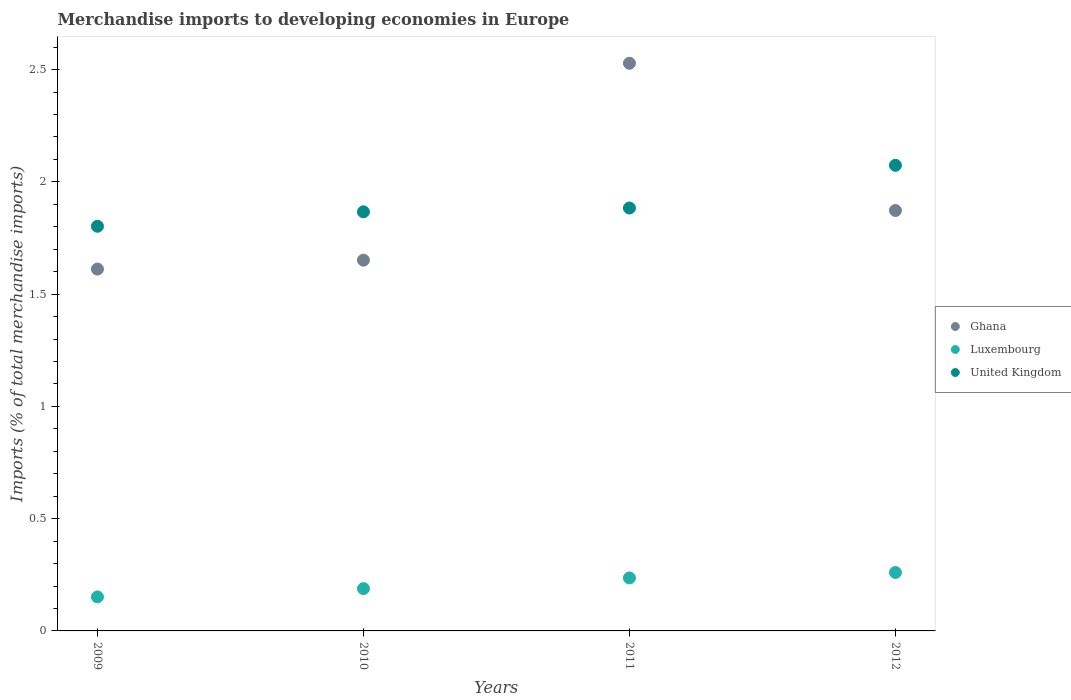How many different coloured dotlines are there?
Your answer should be compact. 3. Is the number of dotlines equal to the number of legend labels?
Your answer should be very brief. Yes. What is the percentage total merchandise imports in Ghana in 2009?
Offer a very short reply. 1.61. Across all years, what is the maximum percentage total merchandise imports in Ghana?
Your response must be concise. 2.53. Across all years, what is the minimum percentage total merchandise imports in Ghana?
Give a very brief answer. 1.61. In which year was the percentage total merchandise imports in Ghana minimum?
Your response must be concise. 2009. What is the total percentage total merchandise imports in Ghana in the graph?
Provide a succinct answer. 7.66. What is the difference between the percentage total merchandise imports in United Kingdom in 2011 and that in 2012?
Your answer should be very brief. -0.19. What is the difference between the percentage total merchandise imports in United Kingdom in 2012 and the percentage total merchandise imports in Luxembourg in 2010?
Make the answer very short. 1.89. What is the average percentage total merchandise imports in Ghana per year?
Give a very brief answer. 1.92. In the year 2010, what is the difference between the percentage total merchandise imports in Luxembourg and percentage total merchandise imports in United Kingdom?
Offer a very short reply. -1.68. In how many years, is the percentage total merchandise imports in Ghana greater than 1 %?
Your answer should be compact. 4. What is the ratio of the percentage total merchandise imports in Luxembourg in 2010 to that in 2011?
Provide a succinct answer. 0.8. Is the percentage total merchandise imports in Ghana in 2011 less than that in 2012?
Your answer should be compact. No. Is the difference between the percentage total merchandise imports in Luxembourg in 2010 and 2012 greater than the difference between the percentage total merchandise imports in United Kingdom in 2010 and 2012?
Ensure brevity in your answer.  Yes. What is the difference between the highest and the second highest percentage total merchandise imports in Ghana?
Give a very brief answer. 0.66. What is the difference between the highest and the lowest percentage total merchandise imports in Ghana?
Your response must be concise. 0.92. Is the sum of the percentage total merchandise imports in Ghana in 2009 and 2010 greater than the maximum percentage total merchandise imports in Luxembourg across all years?
Keep it short and to the point. Yes. Does the percentage total merchandise imports in Luxembourg monotonically increase over the years?
Make the answer very short. Yes. Is the percentage total merchandise imports in Ghana strictly greater than the percentage total merchandise imports in Luxembourg over the years?
Give a very brief answer. Yes. Does the graph contain grids?
Offer a very short reply. No. How many legend labels are there?
Keep it short and to the point. 3. How are the legend labels stacked?
Provide a short and direct response. Vertical. What is the title of the graph?
Provide a short and direct response. Merchandise imports to developing economies in Europe. Does "New Zealand" appear as one of the legend labels in the graph?
Your answer should be very brief. No. What is the label or title of the X-axis?
Your response must be concise. Years. What is the label or title of the Y-axis?
Your answer should be compact. Imports (% of total merchandise imports). What is the Imports (% of total merchandise imports) in Ghana in 2009?
Give a very brief answer. 1.61. What is the Imports (% of total merchandise imports) of Luxembourg in 2009?
Provide a short and direct response. 0.15. What is the Imports (% of total merchandise imports) of United Kingdom in 2009?
Provide a short and direct response. 1.8. What is the Imports (% of total merchandise imports) of Ghana in 2010?
Your answer should be compact. 1.65. What is the Imports (% of total merchandise imports) in Luxembourg in 2010?
Make the answer very short. 0.19. What is the Imports (% of total merchandise imports) of United Kingdom in 2010?
Your answer should be compact. 1.87. What is the Imports (% of total merchandise imports) of Ghana in 2011?
Provide a short and direct response. 2.53. What is the Imports (% of total merchandise imports) of Luxembourg in 2011?
Offer a terse response. 0.24. What is the Imports (% of total merchandise imports) of United Kingdom in 2011?
Your response must be concise. 1.88. What is the Imports (% of total merchandise imports) of Ghana in 2012?
Ensure brevity in your answer.  1.87. What is the Imports (% of total merchandise imports) of Luxembourg in 2012?
Give a very brief answer. 0.26. What is the Imports (% of total merchandise imports) in United Kingdom in 2012?
Provide a succinct answer. 2.07. Across all years, what is the maximum Imports (% of total merchandise imports) in Ghana?
Provide a short and direct response. 2.53. Across all years, what is the maximum Imports (% of total merchandise imports) in Luxembourg?
Provide a short and direct response. 0.26. Across all years, what is the maximum Imports (% of total merchandise imports) of United Kingdom?
Your answer should be compact. 2.07. Across all years, what is the minimum Imports (% of total merchandise imports) in Ghana?
Give a very brief answer. 1.61. Across all years, what is the minimum Imports (% of total merchandise imports) of Luxembourg?
Provide a succinct answer. 0.15. Across all years, what is the minimum Imports (% of total merchandise imports) in United Kingdom?
Your answer should be compact. 1.8. What is the total Imports (% of total merchandise imports) in Ghana in the graph?
Your response must be concise. 7.66. What is the total Imports (% of total merchandise imports) in Luxembourg in the graph?
Give a very brief answer. 0.84. What is the total Imports (% of total merchandise imports) in United Kingdom in the graph?
Your answer should be compact. 7.63. What is the difference between the Imports (% of total merchandise imports) in Ghana in 2009 and that in 2010?
Give a very brief answer. -0.04. What is the difference between the Imports (% of total merchandise imports) in Luxembourg in 2009 and that in 2010?
Offer a terse response. -0.04. What is the difference between the Imports (% of total merchandise imports) in United Kingdom in 2009 and that in 2010?
Offer a terse response. -0.06. What is the difference between the Imports (% of total merchandise imports) of Ghana in 2009 and that in 2011?
Provide a succinct answer. -0.92. What is the difference between the Imports (% of total merchandise imports) of Luxembourg in 2009 and that in 2011?
Make the answer very short. -0.08. What is the difference between the Imports (% of total merchandise imports) in United Kingdom in 2009 and that in 2011?
Give a very brief answer. -0.08. What is the difference between the Imports (% of total merchandise imports) in Ghana in 2009 and that in 2012?
Give a very brief answer. -0.26. What is the difference between the Imports (% of total merchandise imports) in Luxembourg in 2009 and that in 2012?
Keep it short and to the point. -0.11. What is the difference between the Imports (% of total merchandise imports) of United Kingdom in 2009 and that in 2012?
Offer a terse response. -0.27. What is the difference between the Imports (% of total merchandise imports) in Ghana in 2010 and that in 2011?
Provide a short and direct response. -0.88. What is the difference between the Imports (% of total merchandise imports) of Luxembourg in 2010 and that in 2011?
Offer a terse response. -0.05. What is the difference between the Imports (% of total merchandise imports) in United Kingdom in 2010 and that in 2011?
Keep it short and to the point. -0.02. What is the difference between the Imports (% of total merchandise imports) of Ghana in 2010 and that in 2012?
Provide a short and direct response. -0.22. What is the difference between the Imports (% of total merchandise imports) of Luxembourg in 2010 and that in 2012?
Provide a succinct answer. -0.07. What is the difference between the Imports (% of total merchandise imports) in United Kingdom in 2010 and that in 2012?
Your answer should be very brief. -0.21. What is the difference between the Imports (% of total merchandise imports) of Ghana in 2011 and that in 2012?
Provide a short and direct response. 0.66. What is the difference between the Imports (% of total merchandise imports) in Luxembourg in 2011 and that in 2012?
Offer a very short reply. -0.02. What is the difference between the Imports (% of total merchandise imports) in United Kingdom in 2011 and that in 2012?
Ensure brevity in your answer.  -0.19. What is the difference between the Imports (% of total merchandise imports) of Ghana in 2009 and the Imports (% of total merchandise imports) of Luxembourg in 2010?
Your response must be concise. 1.42. What is the difference between the Imports (% of total merchandise imports) in Ghana in 2009 and the Imports (% of total merchandise imports) in United Kingdom in 2010?
Your response must be concise. -0.25. What is the difference between the Imports (% of total merchandise imports) of Luxembourg in 2009 and the Imports (% of total merchandise imports) of United Kingdom in 2010?
Your response must be concise. -1.71. What is the difference between the Imports (% of total merchandise imports) in Ghana in 2009 and the Imports (% of total merchandise imports) in Luxembourg in 2011?
Provide a short and direct response. 1.38. What is the difference between the Imports (% of total merchandise imports) in Ghana in 2009 and the Imports (% of total merchandise imports) in United Kingdom in 2011?
Give a very brief answer. -0.27. What is the difference between the Imports (% of total merchandise imports) in Luxembourg in 2009 and the Imports (% of total merchandise imports) in United Kingdom in 2011?
Offer a terse response. -1.73. What is the difference between the Imports (% of total merchandise imports) of Ghana in 2009 and the Imports (% of total merchandise imports) of Luxembourg in 2012?
Offer a very short reply. 1.35. What is the difference between the Imports (% of total merchandise imports) of Ghana in 2009 and the Imports (% of total merchandise imports) of United Kingdom in 2012?
Your answer should be very brief. -0.46. What is the difference between the Imports (% of total merchandise imports) of Luxembourg in 2009 and the Imports (% of total merchandise imports) of United Kingdom in 2012?
Keep it short and to the point. -1.92. What is the difference between the Imports (% of total merchandise imports) of Ghana in 2010 and the Imports (% of total merchandise imports) of Luxembourg in 2011?
Your answer should be compact. 1.42. What is the difference between the Imports (% of total merchandise imports) in Ghana in 2010 and the Imports (% of total merchandise imports) in United Kingdom in 2011?
Keep it short and to the point. -0.23. What is the difference between the Imports (% of total merchandise imports) of Luxembourg in 2010 and the Imports (% of total merchandise imports) of United Kingdom in 2011?
Your answer should be very brief. -1.7. What is the difference between the Imports (% of total merchandise imports) of Ghana in 2010 and the Imports (% of total merchandise imports) of Luxembourg in 2012?
Make the answer very short. 1.39. What is the difference between the Imports (% of total merchandise imports) of Ghana in 2010 and the Imports (% of total merchandise imports) of United Kingdom in 2012?
Your response must be concise. -0.42. What is the difference between the Imports (% of total merchandise imports) of Luxembourg in 2010 and the Imports (% of total merchandise imports) of United Kingdom in 2012?
Ensure brevity in your answer.  -1.89. What is the difference between the Imports (% of total merchandise imports) of Ghana in 2011 and the Imports (% of total merchandise imports) of Luxembourg in 2012?
Provide a succinct answer. 2.27. What is the difference between the Imports (% of total merchandise imports) in Ghana in 2011 and the Imports (% of total merchandise imports) in United Kingdom in 2012?
Offer a very short reply. 0.45. What is the difference between the Imports (% of total merchandise imports) in Luxembourg in 2011 and the Imports (% of total merchandise imports) in United Kingdom in 2012?
Your answer should be compact. -1.84. What is the average Imports (% of total merchandise imports) of Ghana per year?
Give a very brief answer. 1.92. What is the average Imports (% of total merchandise imports) in Luxembourg per year?
Give a very brief answer. 0.21. What is the average Imports (% of total merchandise imports) in United Kingdom per year?
Give a very brief answer. 1.91. In the year 2009, what is the difference between the Imports (% of total merchandise imports) of Ghana and Imports (% of total merchandise imports) of Luxembourg?
Offer a terse response. 1.46. In the year 2009, what is the difference between the Imports (% of total merchandise imports) in Ghana and Imports (% of total merchandise imports) in United Kingdom?
Ensure brevity in your answer.  -0.19. In the year 2009, what is the difference between the Imports (% of total merchandise imports) of Luxembourg and Imports (% of total merchandise imports) of United Kingdom?
Keep it short and to the point. -1.65. In the year 2010, what is the difference between the Imports (% of total merchandise imports) in Ghana and Imports (% of total merchandise imports) in Luxembourg?
Give a very brief answer. 1.46. In the year 2010, what is the difference between the Imports (% of total merchandise imports) of Ghana and Imports (% of total merchandise imports) of United Kingdom?
Provide a short and direct response. -0.22. In the year 2010, what is the difference between the Imports (% of total merchandise imports) in Luxembourg and Imports (% of total merchandise imports) in United Kingdom?
Provide a succinct answer. -1.68. In the year 2011, what is the difference between the Imports (% of total merchandise imports) in Ghana and Imports (% of total merchandise imports) in Luxembourg?
Provide a succinct answer. 2.29. In the year 2011, what is the difference between the Imports (% of total merchandise imports) of Ghana and Imports (% of total merchandise imports) of United Kingdom?
Provide a short and direct response. 0.64. In the year 2011, what is the difference between the Imports (% of total merchandise imports) of Luxembourg and Imports (% of total merchandise imports) of United Kingdom?
Your response must be concise. -1.65. In the year 2012, what is the difference between the Imports (% of total merchandise imports) in Ghana and Imports (% of total merchandise imports) in Luxembourg?
Your answer should be compact. 1.61. In the year 2012, what is the difference between the Imports (% of total merchandise imports) in Ghana and Imports (% of total merchandise imports) in United Kingdom?
Provide a succinct answer. -0.2. In the year 2012, what is the difference between the Imports (% of total merchandise imports) in Luxembourg and Imports (% of total merchandise imports) in United Kingdom?
Offer a very short reply. -1.81. What is the ratio of the Imports (% of total merchandise imports) in Luxembourg in 2009 to that in 2010?
Provide a succinct answer. 0.8. What is the ratio of the Imports (% of total merchandise imports) of United Kingdom in 2009 to that in 2010?
Your response must be concise. 0.97. What is the ratio of the Imports (% of total merchandise imports) in Ghana in 2009 to that in 2011?
Ensure brevity in your answer.  0.64. What is the ratio of the Imports (% of total merchandise imports) of Luxembourg in 2009 to that in 2011?
Your response must be concise. 0.64. What is the ratio of the Imports (% of total merchandise imports) of United Kingdom in 2009 to that in 2011?
Make the answer very short. 0.96. What is the ratio of the Imports (% of total merchandise imports) of Ghana in 2009 to that in 2012?
Your answer should be very brief. 0.86. What is the ratio of the Imports (% of total merchandise imports) in Luxembourg in 2009 to that in 2012?
Make the answer very short. 0.58. What is the ratio of the Imports (% of total merchandise imports) in United Kingdom in 2009 to that in 2012?
Ensure brevity in your answer.  0.87. What is the ratio of the Imports (% of total merchandise imports) of Ghana in 2010 to that in 2011?
Keep it short and to the point. 0.65. What is the ratio of the Imports (% of total merchandise imports) in Luxembourg in 2010 to that in 2011?
Offer a terse response. 0.8. What is the ratio of the Imports (% of total merchandise imports) of United Kingdom in 2010 to that in 2011?
Give a very brief answer. 0.99. What is the ratio of the Imports (% of total merchandise imports) of Ghana in 2010 to that in 2012?
Your answer should be compact. 0.88. What is the ratio of the Imports (% of total merchandise imports) of Luxembourg in 2010 to that in 2012?
Your answer should be very brief. 0.72. What is the ratio of the Imports (% of total merchandise imports) in United Kingdom in 2010 to that in 2012?
Your answer should be compact. 0.9. What is the ratio of the Imports (% of total merchandise imports) in Ghana in 2011 to that in 2012?
Your response must be concise. 1.35. What is the ratio of the Imports (% of total merchandise imports) of Luxembourg in 2011 to that in 2012?
Make the answer very short. 0.91. What is the ratio of the Imports (% of total merchandise imports) in United Kingdom in 2011 to that in 2012?
Give a very brief answer. 0.91. What is the difference between the highest and the second highest Imports (% of total merchandise imports) of Ghana?
Provide a succinct answer. 0.66. What is the difference between the highest and the second highest Imports (% of total merchandise imports) of Luxembourg?
Give a very brief answer. 0.02. What is the difference between the highest and the second highest Imports (% of total merchandise imports) of United Kingdom?
Keep it short and to the point. 0.19. What is the difference between the highest and the lowest Imports (% of total merchandise imports) in Ghana?
Offer a terse response. 0.92. What is the difference between the highest and the lowest Imports (% of total merchandise imports) of Luxembourg?
Offer a terse response. 0.11. What is the difference between the highest and the lowest Imports (% of total merchandise imports) of United Kingdom?
Keep it short and to the point. 0.27. 